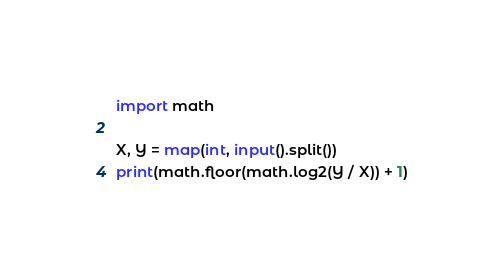Convert code to text. <code><loc_0><loc_0><loc_500><loc_500><_Python_>import math

X, Y = map(int, input().split())
print(math.floor(math.log2(Y / X)) + 1)</code> 